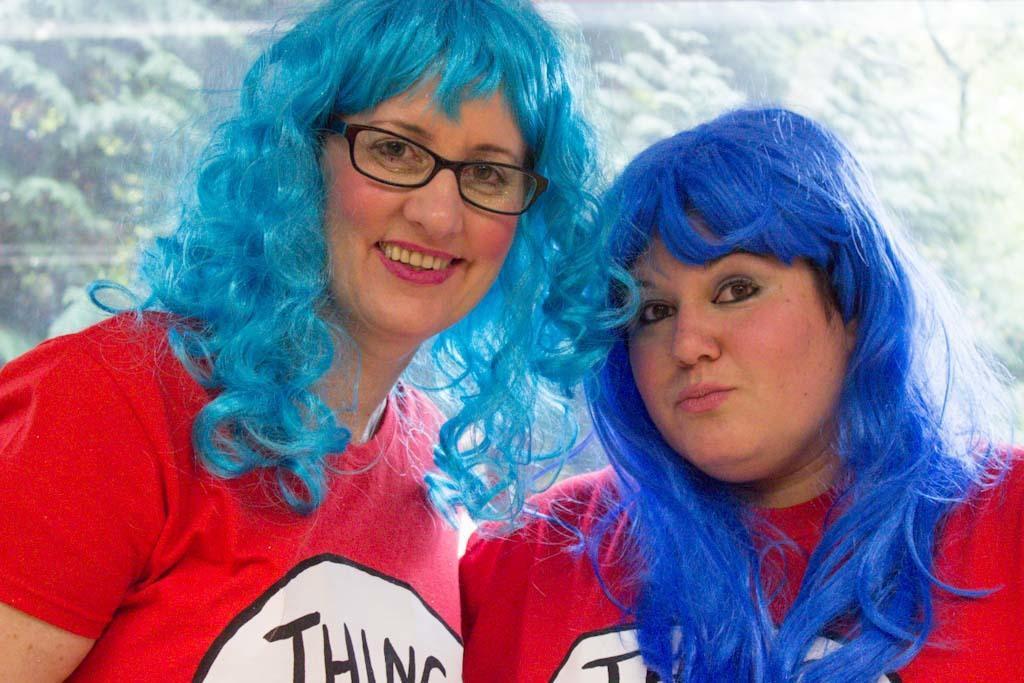In one or two sentences, can you explain what this image depicts? In this image two persons are wearing red shirts. Person at the left side is wearing spectacles. Behind them there are few trees. 